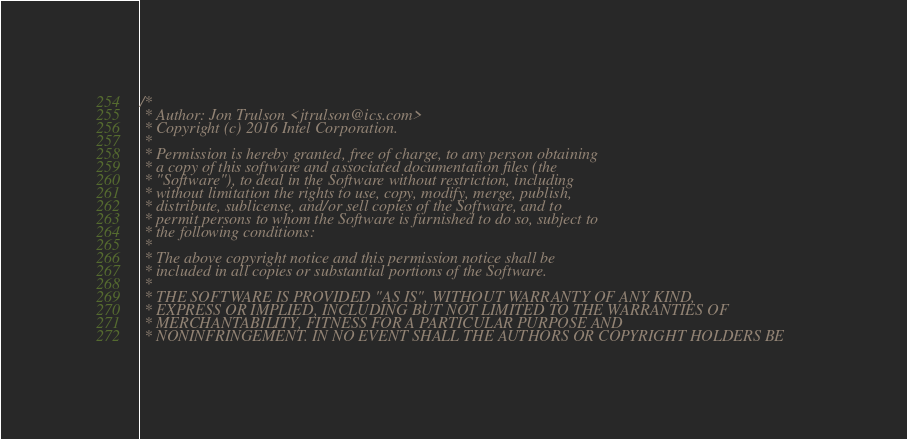<code> <loc_0><loc_0><loc_500><loc_500><_C_>/*
 * Author: Jon Trulson <jtrulson@ics.com>
 * Copyright (c) 2016 Intel Corporation.
 *
 * Permission is hereby granted, free of charge, to any person obtaining
 * a copy of this software and associated documentation files (the
 * "Software"), to deal in the Software without restriction, including
 * without limitation the rights to use, copy, modify, merge, publish,
 * distribute, sublicense, and/or sell copies of the Software, and to
 * permit persons to whom the Software is furnished to do so, subject to
 * the following conditions:
 *
 * The above copyright notice and this permission notice shall be
 * included in all copies or substantial portions of the Software.
 *
 * THE SOFTWARE IS PROVIDED "AS IS", WITHOUT WARRANTY OF ANY KIND,
 * EXPRESS OR IMPLIED, INCLUDING BUT NOT LIMITED TO THE WARRANTIES OF
 * MERCHANTABILITY, FITNESS FOR A PARTICULAR PURPOSE AND
 * NONINFRINGEMENT. IN NO EVENT SHALL THE AUTHORS OR COPYRIGHT HOLDERS BE</code> 